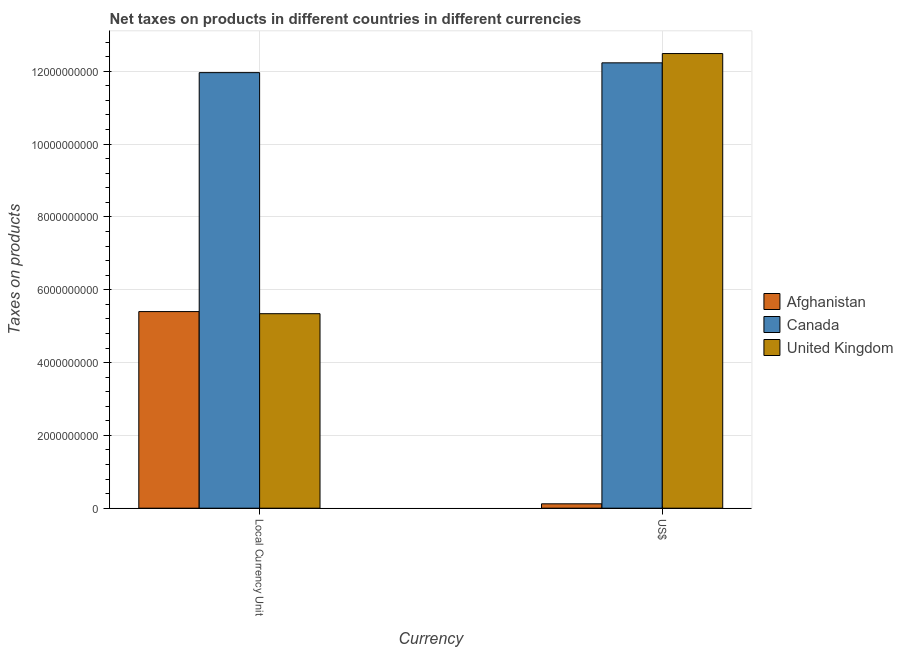How many bars are there on the 1st tick from the left?
Ensure brevity in your answer.  3. What is the label of the 2nd group of bars from the left?
Your response must be concise. US$. What is the net taxes in constant 2005 us$ in Afghanistan?
Offer a very short reply. 5.40e+09. Across all countries, what is the maximum net taxes in constant 2005 us$?
Make the answer very short. 1.20e+1. Across all countries, what is the minimum net taxes in us$?
Offer a terse response. 1.20e+08. In which country was the net taxes in us$ maximum?
Provide a short and direct response. United Kingdom. In which country was the net taxes in constant 2005 us$ minimum?
Make the answer very short. United Kingdom. What is the total net taxes in us$ in the graph?
Your answer should be very brief. 2.48e+1. What is the difference between the net taxes in constant 2005 us$ in Canada and that in United Kingdom?
Your answer should be compact. 6.62e+09. What is the difference between the net taxes in constant 2005 us$ in Canada and the net taxes in us$ in Afghanistan?
Keep it short and to the point. 1.18e+1. What is the average net taxes in constant 2005 us$ per country?
Give a very brief answer. 7.57e+09. What is the difference between the net taxes in us$ and net taxes in constant 2005 us$ in United Kingdom?
Keep it short and to the point. 7.15e+09. What is the ratio of the net taxes in us$ in Canada to that in Afghanistan?
Your answer should be very brief. 101.94. In how many countries, is the net taxes in us$ greater than the average net taxes in us$ taken over all countries?
Provide a short and direct response. 2. What does the 3rd bar from the left in Local Currency Unit represents?
Keep it short and to the point. United Kingdom. What does the 3rd bar from the right in Local Currency Unit represents?
Provide a short and direct response. Afghanistan. Are all the bars in the graph horizontal?
Provide a short and direct response. No. What is the difference between two consecutive major ticks on the Y-axis?
Give a very brief answer. 2.00e+09. How many legend labels are there?
Make the answer very short. 3. How are the legend labels stacked?
Provide a succinct answer. Vertical. What is the title of the graph?
Offer a very short reply. Net taxes on products in different countries in different currencies. Does "Tanzania" appear as one of the legend labels in the graph?
Give a very brief answer. No. What is the label or title of the X-axis?
Your answer should be very brief. Currency. What is the label or title of the Y-axis?
Give a very brief answer. Taxes on products. What is the Taxes on products in Afghanistan in Local Currency Unit?
Offer a very short reply. 5.40e+09. What is the Taxes on products of Canada in Local Currency Unit?
Your response must be concise. 1.20e+1. What is the Taxes on products in United Kingdom in Local Currency Unit?
Offer a very short reply. 5.34e+09. What is the Taxes on products in Afghanistan in US$?
Your response must be concise. 1.20e+08. What is the Taxes on products of Canada in US$?
Keep it short and to the point. 1.22e+1. What is the Taxes on products in United Kingdom in US$?
Keep it short and to the point. 1.25e+1. Across all Currency, what is the maximum Taxes on products of Afghanistan?
Offer a terse response. 5.40e+09. Across all Currency, what is the maximum Taxes on products of Canada?
Make the answer very short. 1.22e+1. Across all Currency, what is the maximum Taxes on products in United Kingdom?
Keep it short and to the point. 1.25e+1. Across all Currency, what is the minimum Taxes on products in Afghanistan?
Ensure brevity in your answer.  1.20e+08. Across all Currency, what is the minimum Taxes on products in Canada?
Keep it short and to the point. 1.20e+1. Across all Currency, what is the minimum Taxes on products of United Kingdom?
Provide a succinct answer. 5.34e+09. What is the total Taxes on products of Afghanistan in the graph?
Your answer should be very brief. 5.52e+09. What is the total Taxes on products in Canada in the graph?
Your answer should be compact. 2.42e+1. What is the total Taxes on products of United Kingdom in the graph?
Provide a short and direct response. 1.78e+1. What is the difference between the Taxes on products of Afghanistan in Local Currency Unit and that in US$?
Provide a short and direct response. 5.28e+09. What is the difference between the Taxes on products of Canada in Local Currency Unit and that in US$?
Provide a short and direct response. -2.69e+08. What is the difference between the Taxes on products of United Kingdom in Local Currency Unit and that in US$?
Give a very brief answer. -7.15e+09. What is the difference between the Taxes on products in Afghanistan in Local Currency Unit and the Taxes on products in Canada in US$?
Ensure brevity in your answer.  -6.83e+09. What is the difference between the Taxes on products in Afghanistan in Local Currency Unit and the Taxes on products in United Kingdom in US$?
Provide a succinct answer. -7.09e+09. What is the difference between the Taxes on products of Canada in Local Currency Unit and the Taxes on products of United Kingdom in US$?
Provide a short and direct response. -5.24e+08. What is the average Taxes on products of Afghanistan per Currency?
Your response must be concise. 2.76e+09. What is the average Taxes on products in Canada per Currency?
Keep it short and to the point. 1.21e+1. What is the average Taxes on products of United Kingdom per Currency?
Provide a short and direct response. 8.91e+09. What is the difference between the Taxes on products of Afghanistan and Taxes on products of Canada in Local Currency Unit?
Ensure brevity in your answer.  -6.56e+09. What is the difference between the Taxes on products of Afghanistan and Taxes on products of United Kingdom in Local Currency Unit?
Ensure brevity in your answer.  5.78e+07. What is the difference between the Taxes on products in Canada and Taxes on products in United Kingdom in Local Currency Unit?
Give a very brief answer. 6.62e+09. What is the difference between the Taxes on products of Afghanistan and Taxes on products of Canada in US$?
Your answer should be compact. -1.21e+1. What is the difference between the Taxes on products in Afghanistan and Taxes on products in United Kingdom in US$?
Make the answer very short. -1.24e+1. What is the difference between the Taxes on products in Canada and Taxes on products in United Kingdom in US$?
Offer a very short reply. -2.55e+08. What is the ratio of the Taxes on products of Canada in Local Currency Unit to that in US$?
Your answer should be very brief. 0.98. What is the ratio of the Taxes on products of United Kingdom in Local Currency Unit to that in US$?
Provide a succinct answer. 0.43. What is the difference between the highest and the second highest Taxes on products in Afghanistan?
Make the answer very short. 5.28e+09. What is the difference between the highest and the second highest Taxes on products of Canada?
Your response must be concise. 2.69e+08. What is the difference between the highest and the second highest Taxes on products of United Kingdom?
Keep it short and to the point. 7.15e+09. What is the difference between the highest and the lowest Taxes on products in Afghanistan?
Your answer should be compact. 5.28e+09. What is the difference between the highest and the lowest Taxes on products in Canada?
Provide a short and direct response. 2.69e+08. What is the difference between the highest and the lowest Taxes on products of United Kingdom?
Provide a succinct answer. 7.15e+09. 